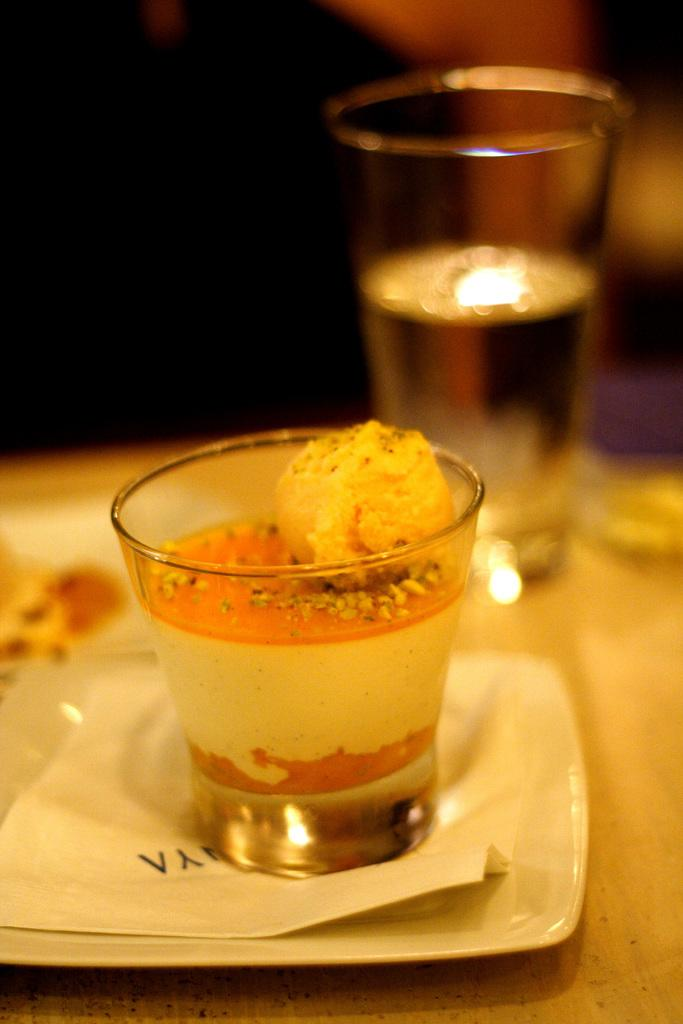What is located at the bottom of the image? There is a table at the bottom of the image. What is placed on the table? There is a plate on the table. What is on the plate? There is a paper and glasses in the plate. Can you describe the background of the image? The background of the image is blurred. What type of cap is being used to invent a new technology in the image? There is no cap or invention present in the image; it only features a table, plate, paper, and glasses. 